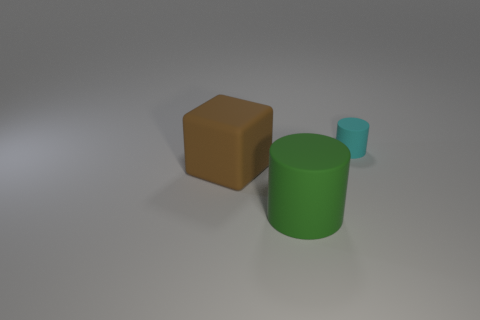Add 3 tiny cyan metallic cubes. How many objects exist? 6 Subtract all green cylinders. How many cylinders are left? 1 Subtract all cylinders. How many objects are left? 1 Subtract 2 cylinders. How many cylinders are left? 0 Subtract all yellow cylinders. Subtract all blue balls. How many cylinders are left? 2 Subtract all purple cylinders. How many green cubes are left? 0 Subtract all yellow matte balls. Subtract all large green cylinders. How many objects are left? 2 Add 3 brown matte blocks. How many brown matte blocks are left? 4 Add 3 blocks. How many blocks exist? 4 Subtract 0 gray balls. How many objects are left? 3 